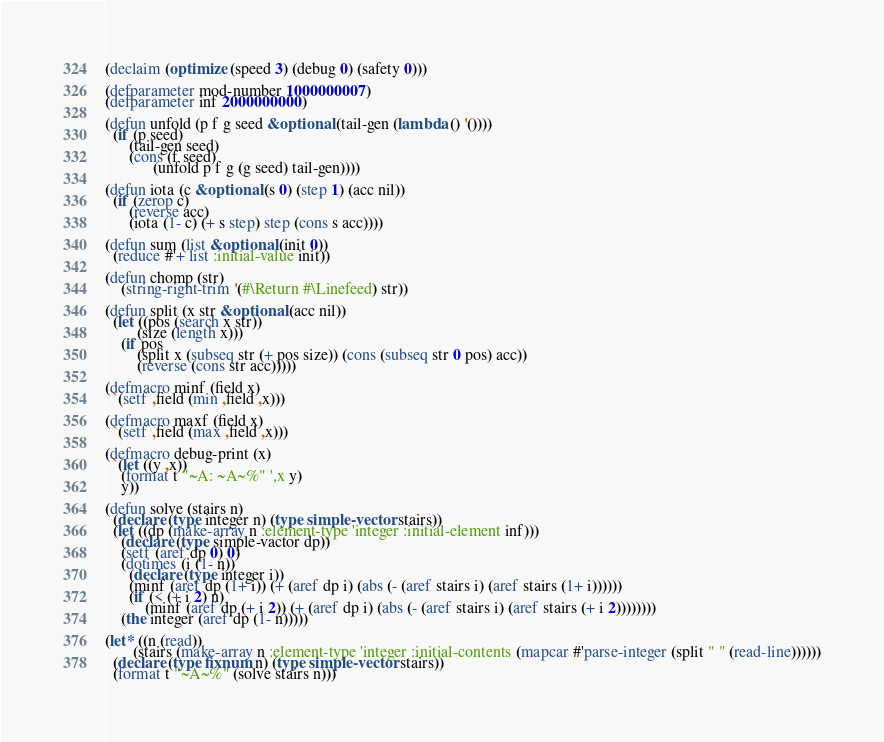Convert code to text. <code><loc_0><loc_0><loc_500><loc_500><_Lisp_>(declaim (optimize (speed 3) (debug 0) (safety 0)))

(defparameter mod-number 1000000007)
(defparameter inf 2000000000)

(defun unfold (p f g seed &optional (tail-gen (lambda () '())))
  (if (p seed)
      (tail-gen seed)
	  (cons (f seed)
	        (unfold p f g (g seed) tail-gen))))
  
(defun iota (c &optional (s 0) (step 1) (acc nil))
  (if (zerop c)
      (reverse acc)
      (iota (1- c) (+ s step) step (cons s acc))))
 
(defun sum (list &optional (init 0))
  (reduce #'+ list :initial-value init))
 
(defun chomp (str)
    (string-right-trim '(#\Return #\Linefeed) str))

(defun split (x str &optional (acc nil))
  (let ((pos (search x str))
        (size (length x)))
    (if pos
        (split x (subseq str (+ pos size)) (cons (subseq str 0 pos) acc))
        (reverse (cons str acc)))))

(defmacro minf (field x)
  `(setf ,field (min ,field ,x)))

(defmacro maxf (field x)
  `(setf ,field (max ,field ,x)))

(defmacro debug-print (x)
  `(let ((y ,x))
    (format t "~A: ~A~%" ',x y)
	y))

(defun solve (stairs n)
  (declare (type integer n) (type simple-vector stairs))
  (let ((dp (make-array n :element-type 'integer :initial-element inf)))
    (declare (type simple-vactor dp))
    (setf (aref dp 0) 0)
    (dotimes (i (1- n))
      (declare (type integer i))
      (minf (aref dp (1+ i)) (+ (aref dp i) (abs (- (aref stairs i) (aref stairs (1+ i))))))
      (if (< (+ i 2) n)
          (minf (aref dp (+ i 2)) (+ (aref dp i) (abs (- (aref stairs i) (aref stairs (+ i 2))))))))
    (the integer (aref dp (1- n)))))

(let* ((n (read))
       (stairs (make-array n :element-type 'integer :initial-contents (mapcar #'parse-integer (split " " (read-line))))))
  (declare (type fixnum n) (type simple-vector stairs))
  (format t "~A~%" (solve stairs n)))
</code> 